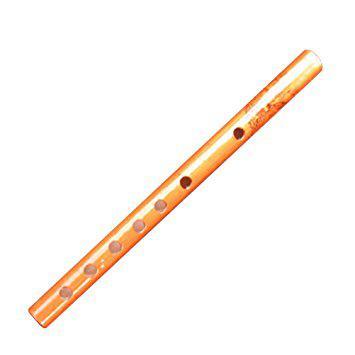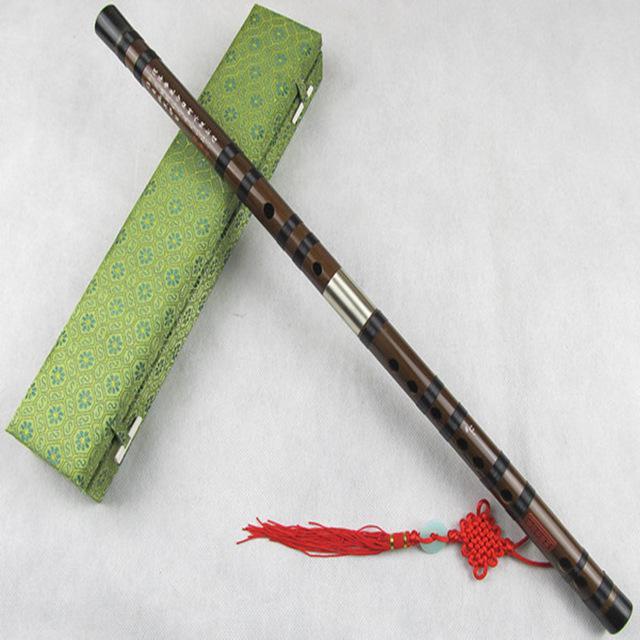The first image is the image on the left, the second image is the image on the right. For the images displayed, is the sentence "There are exactly two flutes." factually correct? Answer yes or no. Yes. The first image is the image on the left, the second image is the image on the right. Evaluate the accuracy of this statement regarding the images: "At least 2 flutes are laying on a wood plank table.". Is it true? Answer yes or no. No. 